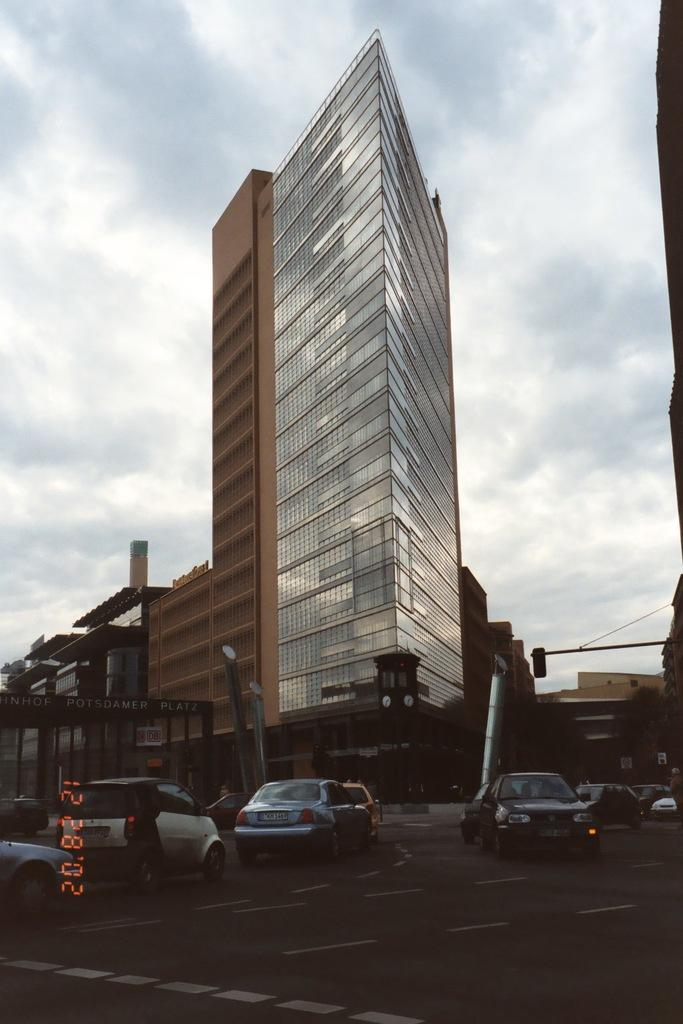What can be seen on the road in the image? There are vehicles on the road in the image. What type of structures are visible in the image? There are buildings in the image. What helps regulate traffic in the image? There are traffic signals in the image. What time does the clock show in the image? There is no clock present in the image. How can the traffic signals be used to solve a riddle in the image? There is no riddle present in the image, and the traffic signals are not used for solving riddles. 